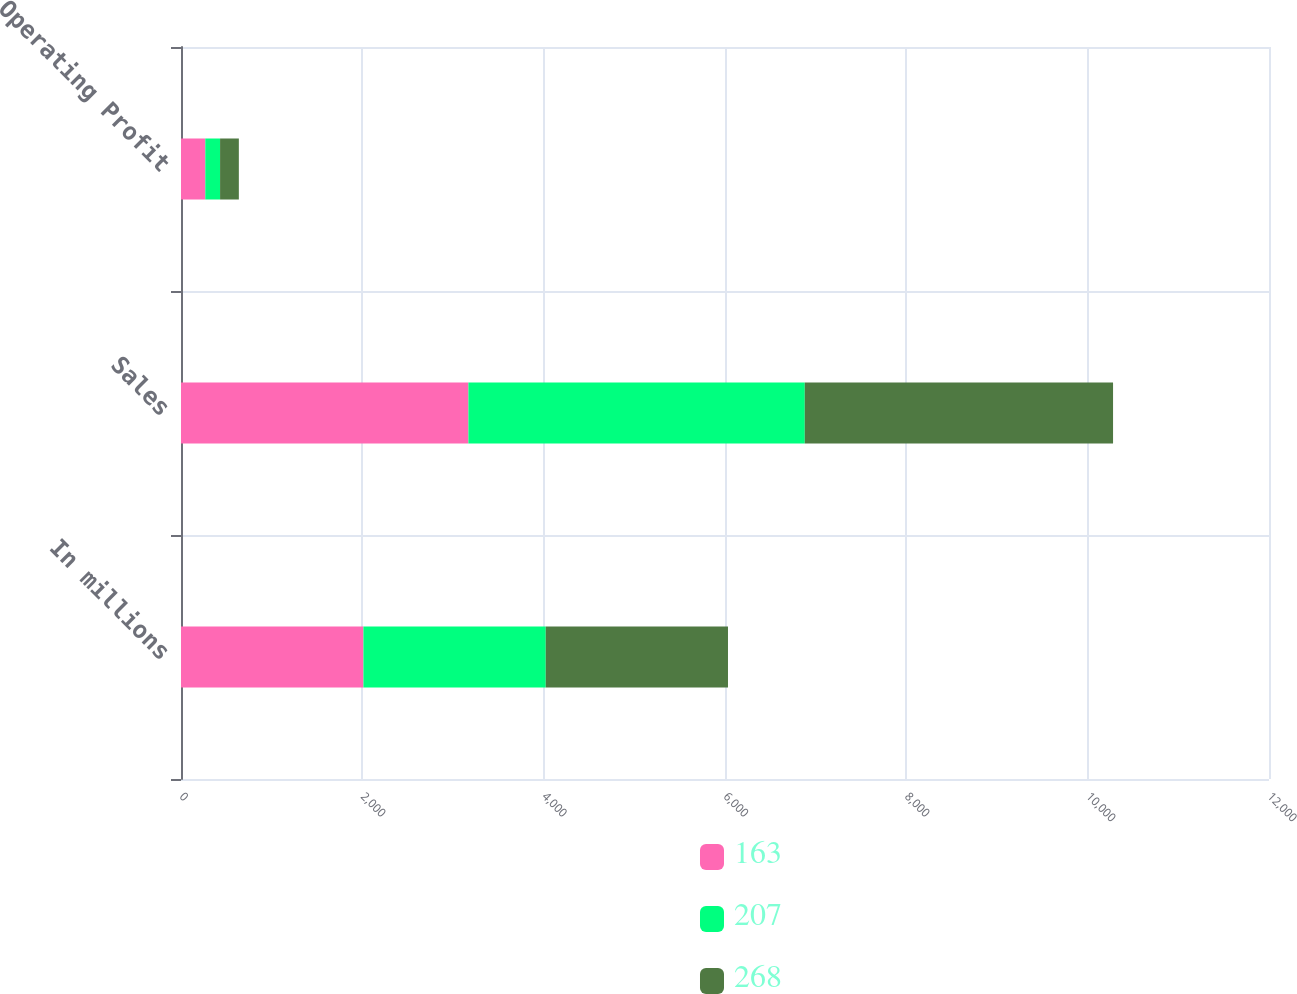<chart> <loc_0><loc_0><loc_500><loc_500><stacked_bar_chart><ecel><fcel>In millions<fcel>Sales<fcel>Operating Profit<nl><fcel>163<fcel>2012<fcel>3170<fcel>268<nl><fcel>207<fcel>2011<fcel>3710<fcel>163<nl><fcel>268<fcel>2010<fcel>3400<fcel>207<nl></chart> 